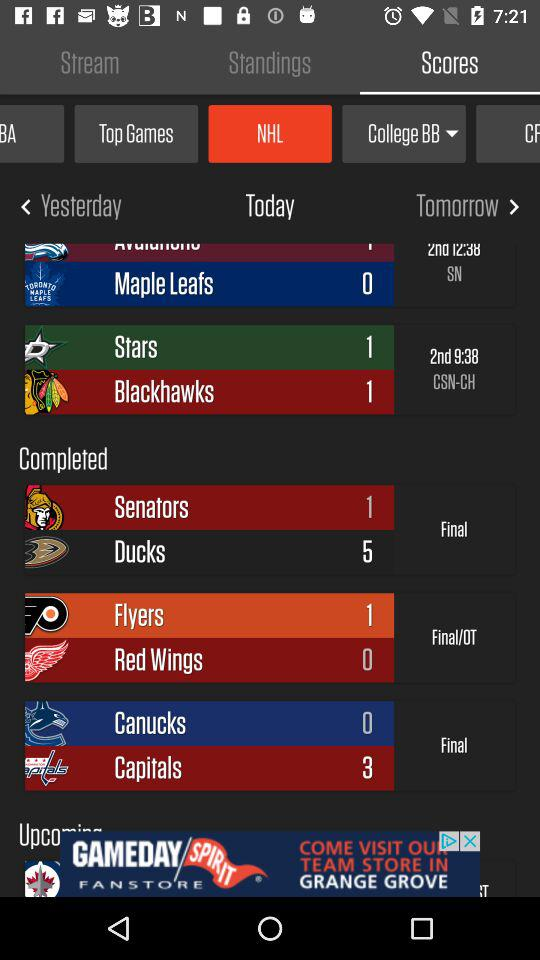What is the time of the second round of "Stars" and "Blackhawks"? The time of the second round is 9:38. 